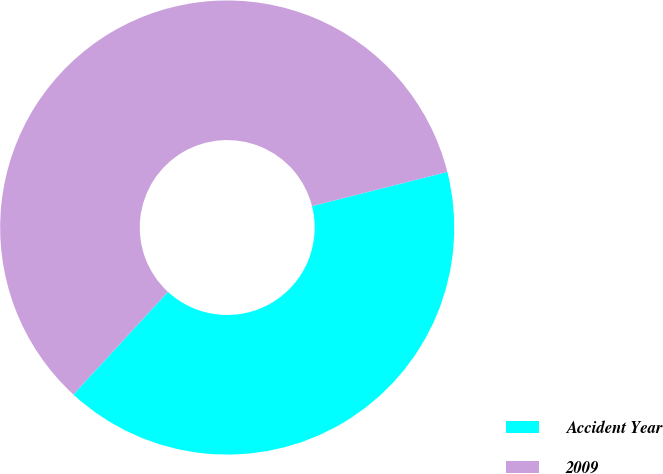Convert chart to OTSL. <chart><loc_0><loc_0><loc_500><loc_500><pie_chart><fcel>Accident Year<fcel>2009<nl><fcel>40.79%<fcel>59.21%<nl></chart> 